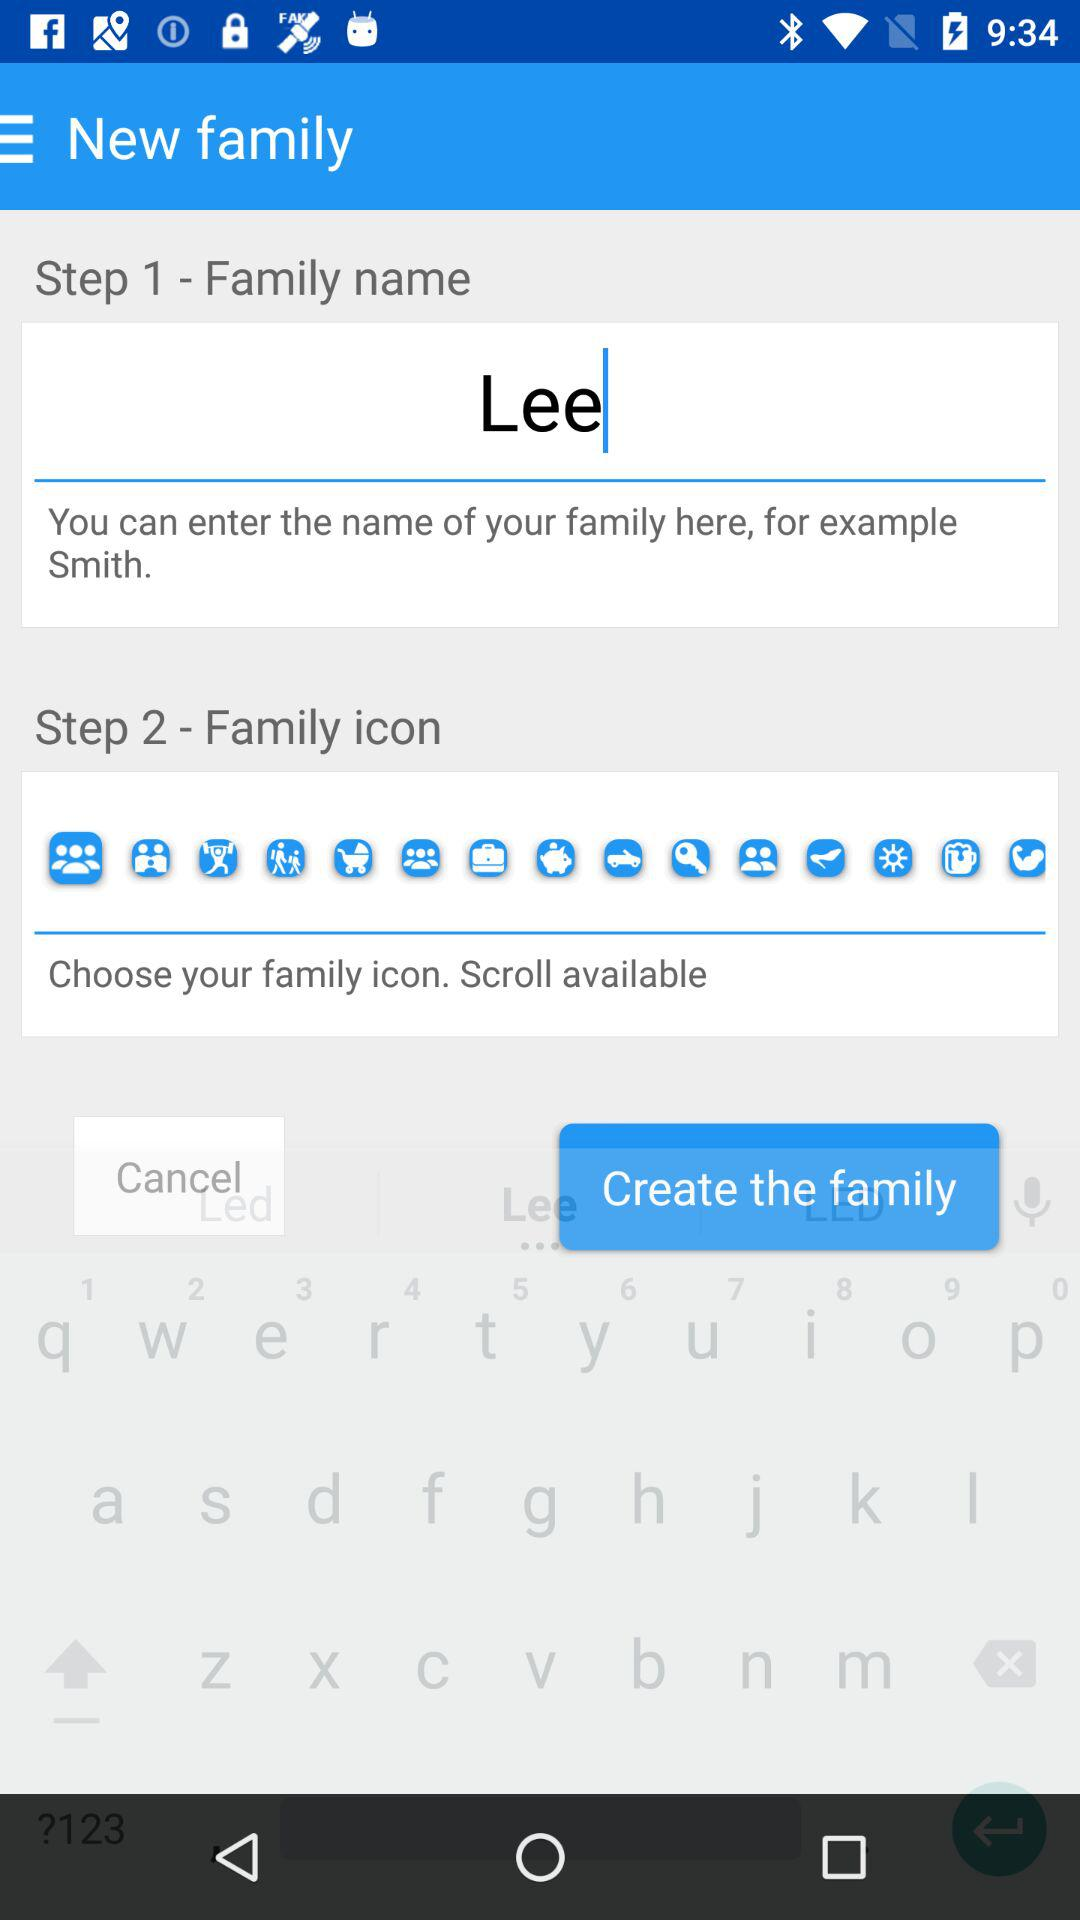What is the family name? The family name is Lee. 